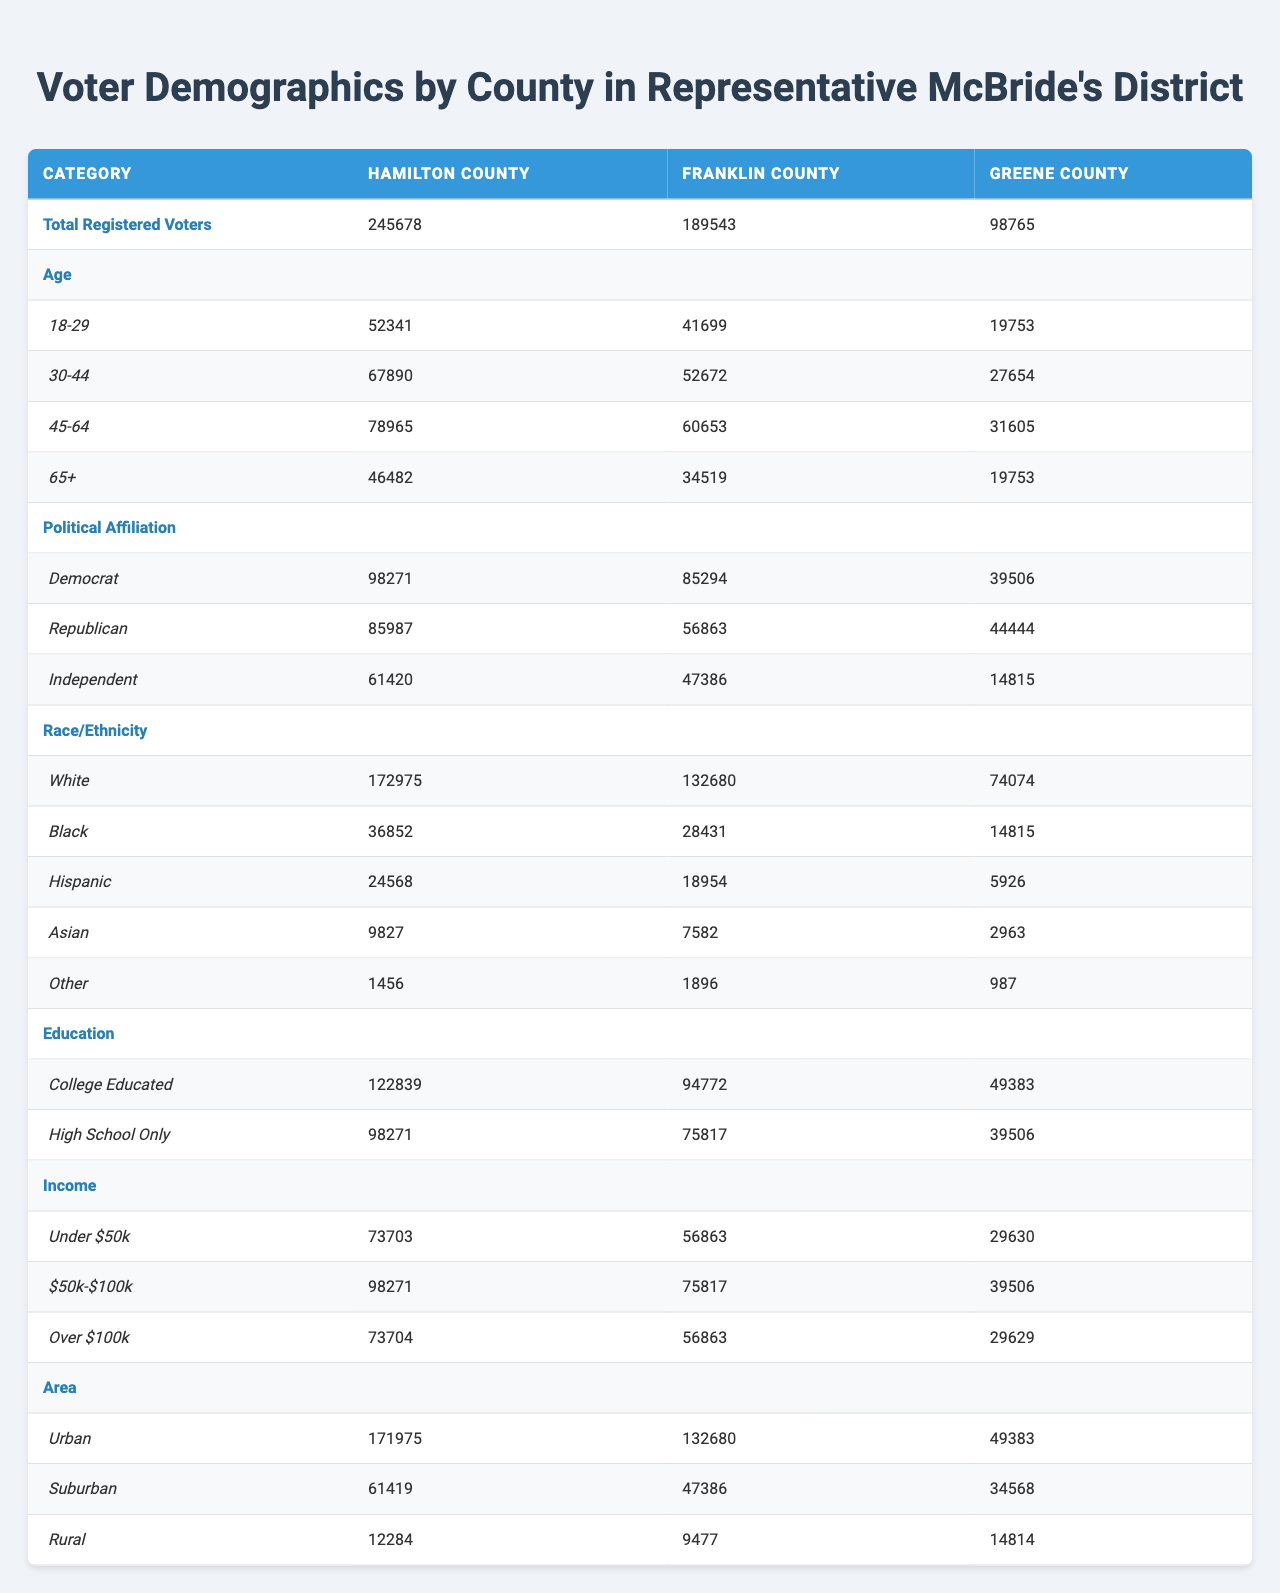What is the total number of registered voters in Hamilton County? The table shows the category "Total Registered Voters" for Hamilton County, which is listed as 245,678.
Answer: 245678 How many Democrats are registered to vote in Franklin County? In the table, under the "Political Affiliation" section, the count of registered Democrats in Franklin County is directly listed as 85,294.
Answer: 85294 What percentage of registered voters in Greene County are 18-29 years old? The total number of registered voters in Greene County is 98,765, and the number of voters aged 18-29 is 19,753. To calculate the percentage, divide 19,753 by 98,765 and multiply by 100, resulting in approximately 19.96%.
Answer: 19.96% Which county has the highest number of college-educated voters? In the Education section of the table, Hamilton County has 122,839 college-educated voters, which is higher than the other counties listed (Franklin and Greene).
Answer: Hamilton County What is the difference in the number of income-earning voters under $50k between Hamilton County and Greene County? For Hamilton County, the number of voters earning under $50k is 73,703, and for Greene County, it's 29,630. The difference is calculated as 73,703 - 29,630, which equals 44,073.
Answer: 44073 Is the number of independent voters in Franklin County greater than 50,000? The table shows that the number of independent voters in Franklin County is 47,386, which is less than 50,000, making the statement false.
Answer: No What is the total number of voters aged 45-64 across all counties? The number of voters aged 45-64 in Hamilton County is 78,965, in Franklin County it's 60,653, and in Greene County, it's 31,605. To find the total, sum these values: 78,965 + 60,653 + 31,605 = 171,223.
Answer: 171223 Which county has the highest percentage of suburban voters compared to urban voters? For Hamilton County, there are 61,419 suburban voters out of 171,975 urban voters, giving a ratio of 61,419 / 171,975 ≈ 0.357 (35.7%). In Franklin County, the ratio is 47,386 / 132,680 ≈ 0.357 (35.7%). For Greene County, it’s 34,568 / 49,383 ≈ 0.699 (69.9%). The highest percentage is from Greene County.
Answer: Greene County How many registered Republicans are there in Hamilton County compared to Franklin County? Hamilton County has 85,987 registered Republicans, while Franklin County has 56,863. To find how many more Republicans are in Hamilton County, subtract: 85,987 - 56,863 = 29,124. Therefore, there are 29,124 more Republicans in Hamilton County than in Franklin County.
Answer: 29124 What is the median age group of voters in Franklin County? The age groups provided are intervals, but we can observe that the largest groups appear to fall within the middle age range (30-44 and 45-64), with numbers 52,672 and 60,653, respectively. Looking for the middle value leads us to the age group between 30-44 and 45-64. Thus, the median age group can be inferred to be between these two categories.
Answer: 30-44 and 45-64 